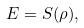Convert formula to latex. <formula><loc_0><loc_0><loc_500><loc_500>E = S ( \rho ) ,</formula> 